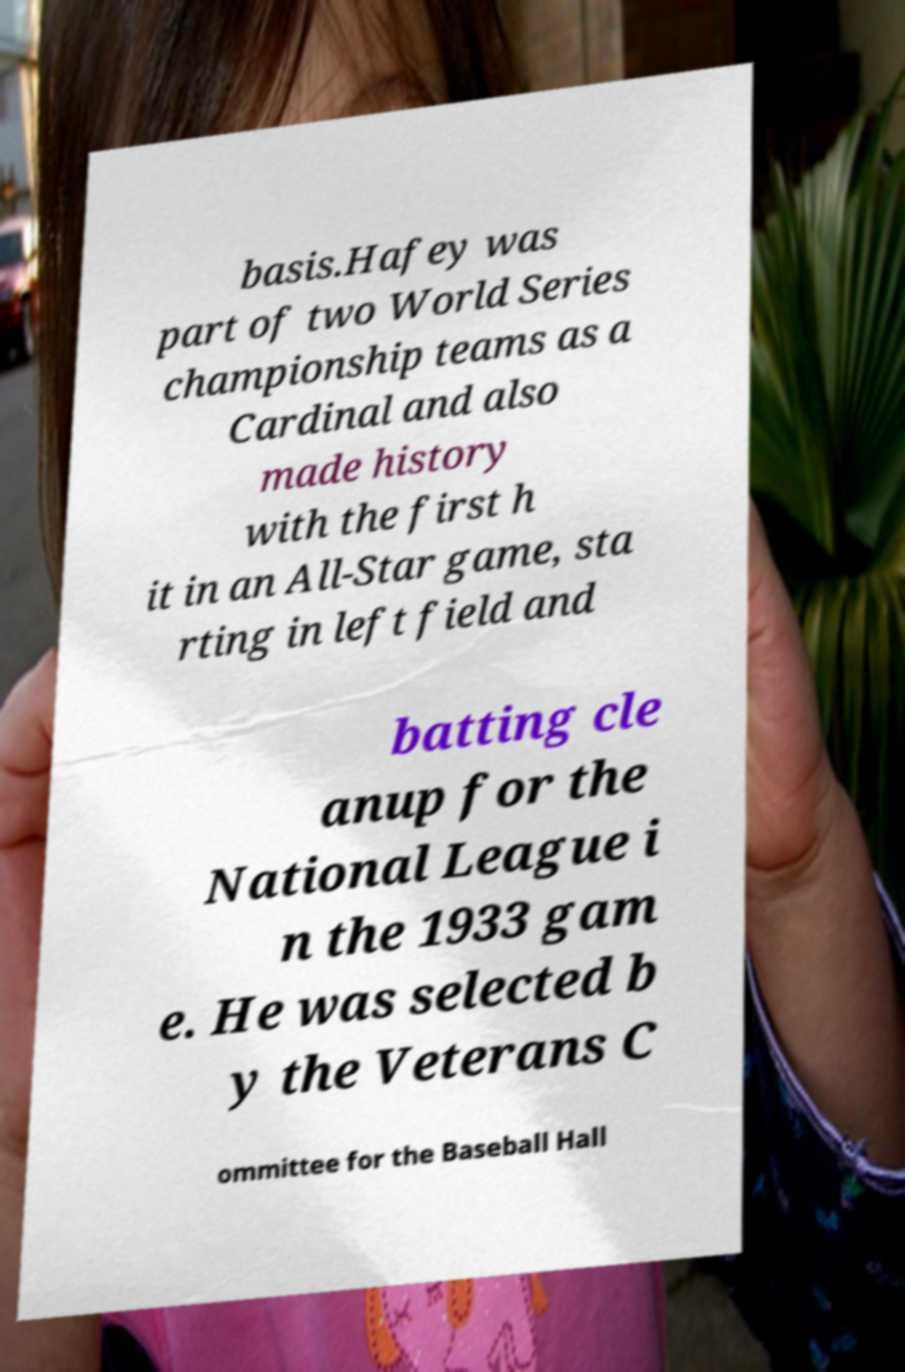For documentation purposes, I need the text within this image transcribed. Could you provide that? basis.Hafey was part of two World Series championship teams as a Cardinal and also made history with the first h it in an All-Star game, sta rting in left field and batting cle anup for the National League i n the 1933 gam e. He was selected b y the Veterans C ommittee for the Baseball Hall 